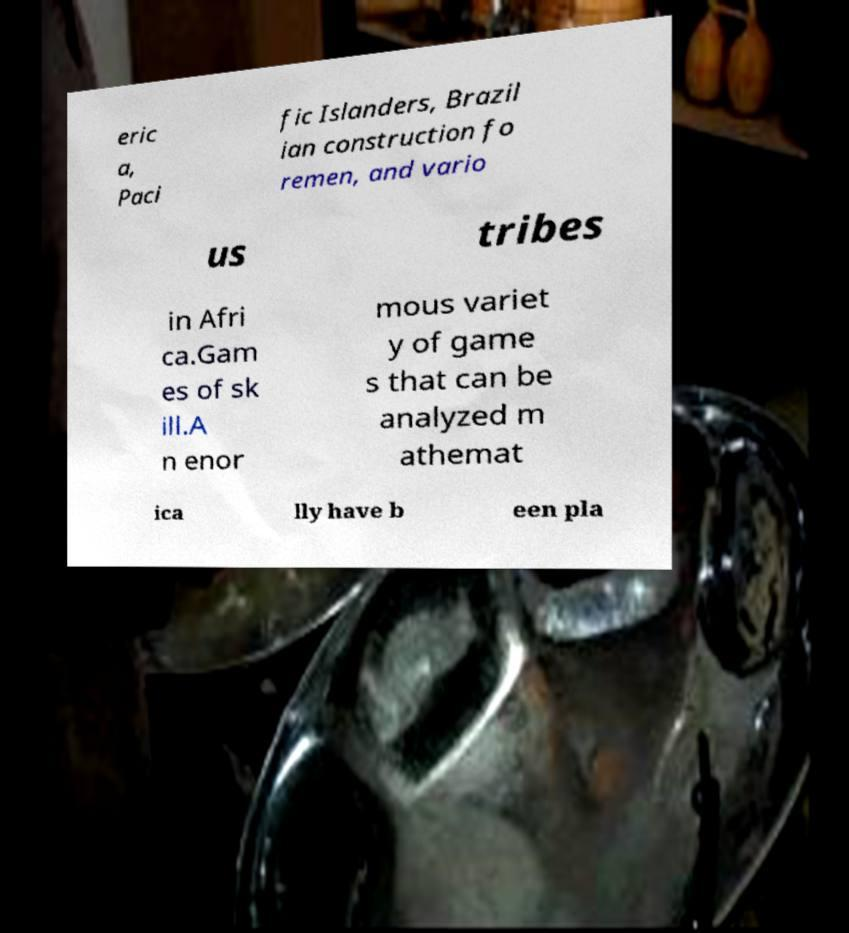There's text embedded in this image that I need extracted. Can you transcribe it verbatim? eric a, Paci fic Islanders, Brazil ian construction fo remen, and vario us tribes in Afri ca.Gam es of sk ill.A n enor mous variet y of game s that can be analyzed m athemat ica lly have b een pla 